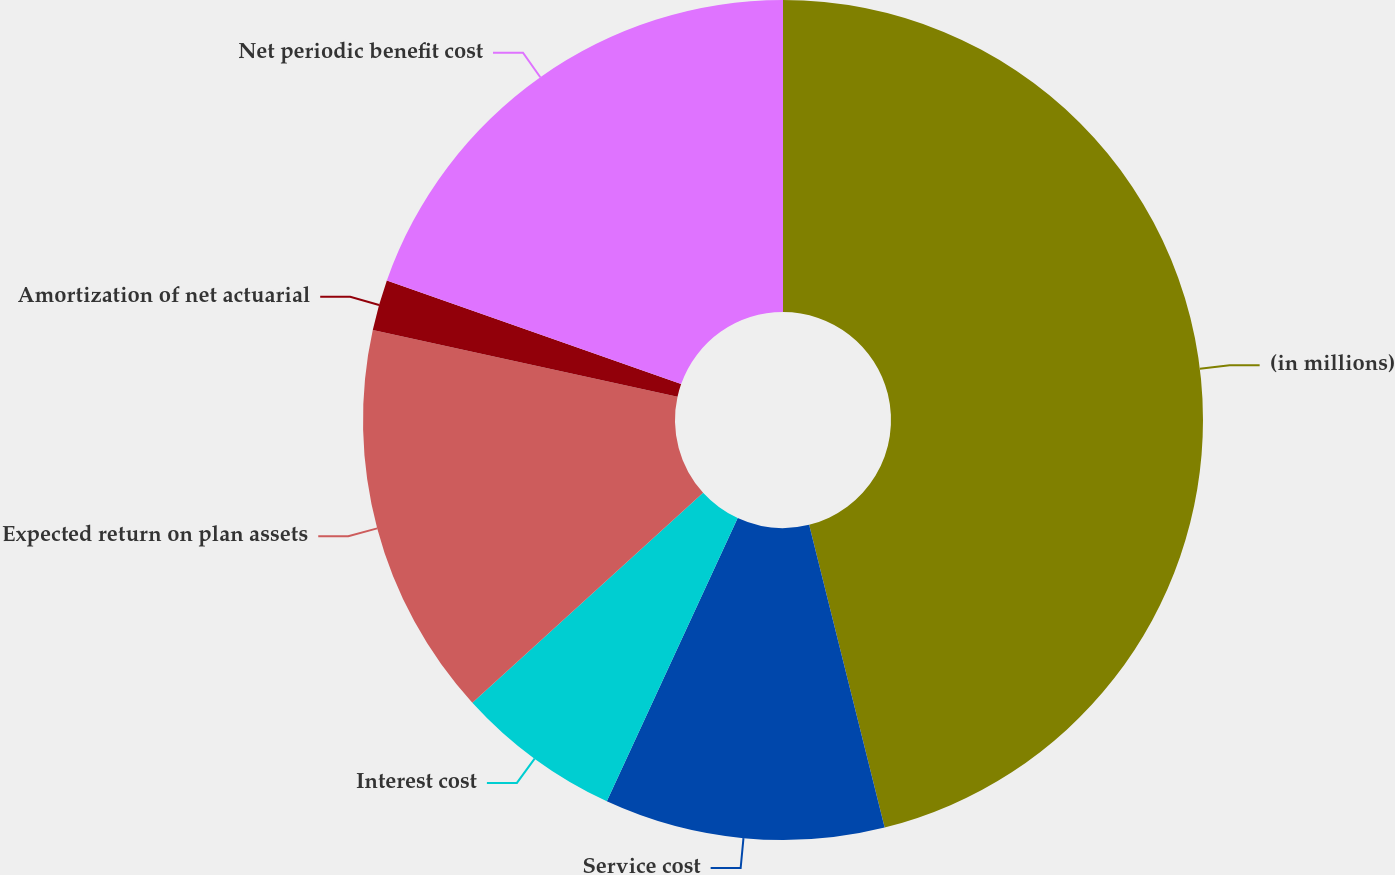Convert chart. <chart><loc_0><loc_0><loc_500><loc_500><pie_chart><fcel>(in millions)<fcel>Service cost<fcel>Interest cost<fcel>Expected return on plan assets<fcel>Amortization of net actuarial<fcel>Net periodic benefit cost<nl><fcel>46.11%<fcel>10.78%<fcel>6.36%<fcel>15.19%<fcel>1.95%<fcel>19.61%<nl></chart> 